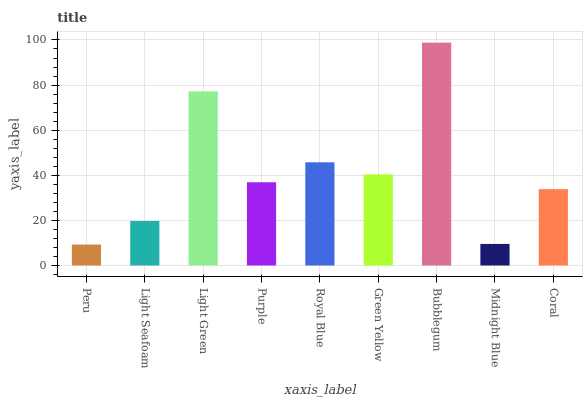Is Peru the minimum?
Answer yes or no. Yes. Is Bubblegum the maximum?
Answer yes or no. Yes. Is Light Seafoam the minimum?
Answer yes or no. No. Is Light Seafoam the maximum?
Answer yes or no. No. Is Light Seafoam greater than Peru?
Answer yes or no. Yes. Is Peru less than Light Seafoam?
Answer yes or no. Yes. Is Peru greater than Light Seafoam?
Answer yes or no. No. Is Light Seafoam less than Peru?
Answer yes or no. No. Is Purple the high median?
Answer yes or no. Yes. Is Purple the low median?
Answer yes or no. Yes. Is Light Seafoam the high median?
Answer yes or no. No. Is Royal Blue the low median?
Answer yes or no. No. 